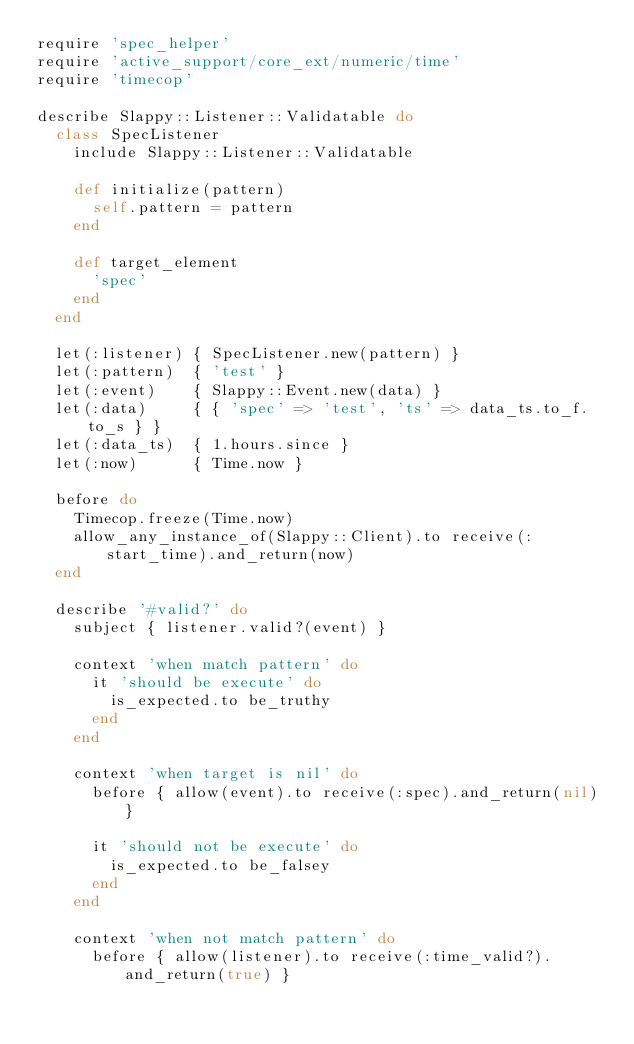<code> <loc_0><loc_0><loc_500><loc_500><_Ruby_>require 'spec_helper'
require 'active_support/core_ext/numeric/time'
require 'timecop'

describe Slappy::Listener::Validatable do
  class SpecListener
    include Slappy::Listener::Validatable

    def initialize(pattern)
      self.pattern = pattern
    end

    def target_element
      'spec'
    end
  end

  let(:listener) { SpecListener.new(pattern) }
  let(:pattern)  { 'test' }
  let(:event)    { Slappy::Event.new(data) }
  let(:data)     { { 'spec' => 'test', 'ts' => data_ts.to_f.to_s } }
  let(:data_ts)  { 1.hours.since }
  let(:now)      { Time.now }

  before do
    Timecop.freeze(Time.now)
    allow_any_instance_of(Slappy::Client).to receive(:start_time).and_return(now)
  end

  describe '#valid?' do
    subject { listener.valid?(event) }

    context 'when match pattern' do
      it 'should be execute' do
        is_expected.to be_truthy
      end
    end

    context 'when target is nil' do
      before { allow(event).to receive(:spec).and_return(nil) }

      it 'should not be execute' do
        is_expected.to be_falsey
      end
    end

    context 'when not match pattern' do
      before { allow(listener).to receive(:time_valid?).and_return(true) }</code> 